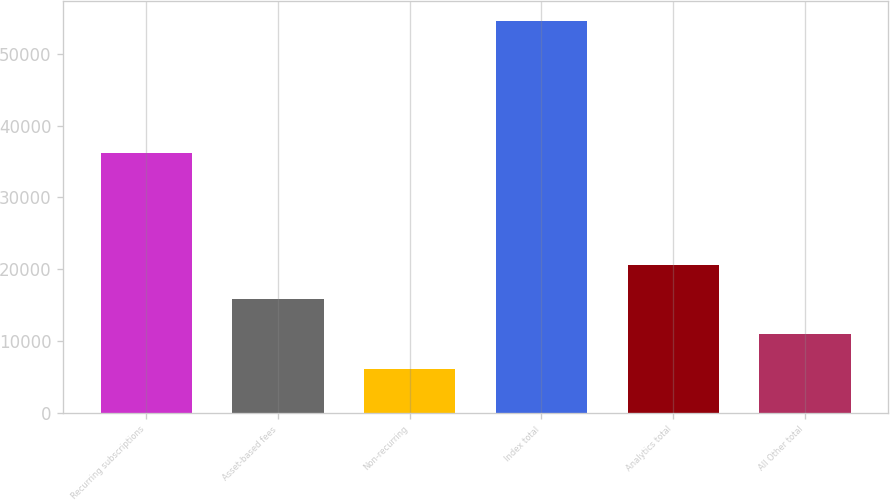Convert chart. <chart><loc_0><loc_0><loc_500><loc_500><bar_chart><fcel>Recurring subscriptions<fcel>Asset-based fees<fcel>Non-recurring<fcel>Index total<fcel>Analytics total<fcel>All Other total<nl><fcel>36212<fcel>15813.4<fcel>6120<fcel>54587<fcel>20660.1<fcel>10966.7<nl></chart> 